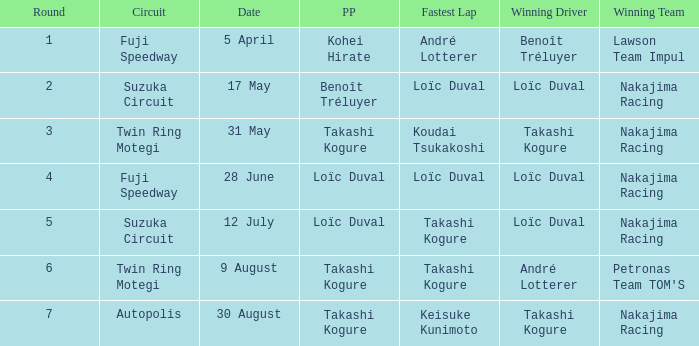Who was the driver for the winning team Lawson Team Impul? Benoît Tréluyer. 